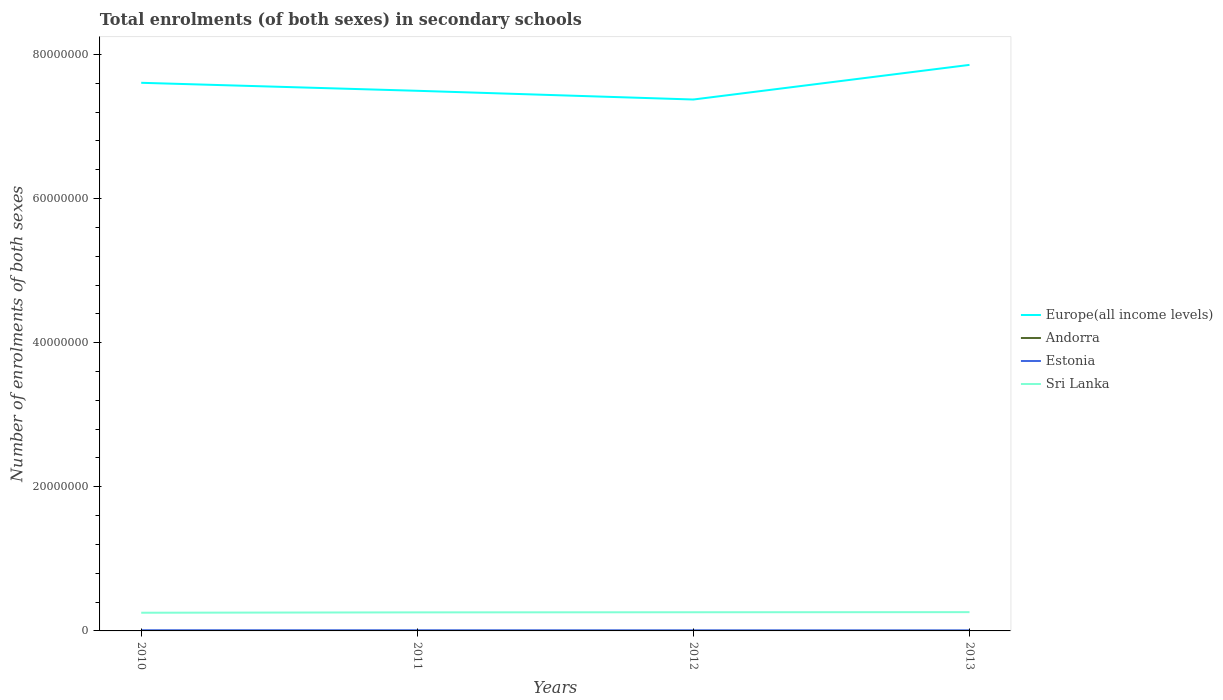Does the line corresponding to Europe(all income levels) intersect with the line corresponding to Andorra?
Keep it short and to the point. No. Across all years, what is the maximum number of enrolments in secondary schools in Estonia?
Ensure brevity in your answer.  8.08e+04. What is the total number of enrolments in secondary schools in Estonia in the graph?
Your response must be concise. 1.45e+04. What is the difference between the highest and the second highest number of enrolments in secondary schools in Estonia?
Your answer should be compact. 1.45e+04. Is the number of enrolments in secondary schools in Sri Lanka strictly greater than the number of enrolments in secondary schools in Andorra over the years?
Your answer should be compact. No. What is the difference between two consecutive major ticks on the Y-axis?
Offer a very short reply. 2.00e+07. Are the values on the major ticks of Y-axis written in scientific E-notation?
Offer a very short reply. No. Does the graph contain any zero values?
Give a very brief answer. No. How many legend labels are there?
Your response must be concise. 4. How are the legend labels stacked?
Provide a short and direct response. Vertical. What is the title of the graph?
Provide a succinct answer. Total enrolments (of both sexes) in secondary schools. What is the label or title of the X-axis?
Your response must be concise. Years. What is the label or title of the Y-axis?
Your answer should be compact. Number of enrolments of both sexes. What is the Number of enrolments of both sexes of Europe(all income levels) in 2010?
Make the answer very short. 7.61e+07. What is the Number of enrolments of both sexes of Andorra in 2010?
Keep it short and to the point. 4059. What is the Number of enrolments of both sexes of Estonia in 2010?
Your response must be concise. 9.53e+04. What is the Number of enrolments of both sexes in Sri Lanka in 2010?
Offer a terse response. 2.52e+06. What is the Number of enrolments of both sexes of Europe(all income levels) in 2011?
Provide a succinct answer. 7.50e+07. What is the Number of enrolments of both sexes in Andorra in 2011?
Offer a terse response. 4159. What is the Number of enrolments of both sexes in Estonia in 2011?
Ensure brevity in your answer.  9.07e+04. What is the Number of enrolments of both sexes of Sri Lanka in 2011?
Keep it short and to the point. 2.57e+06. What is the Number of enrolments of both sexes of Europe(all income levels) in 2012?
Provide a succinct answer. 7.37e+07. What is the Number of enrolments of both sexes in Andorra in 2012?
Offer a terse response. 4208. What is the Number of enrolments of both sexes in Estonia in 2012?
Offer a very short reply. 8.52e+04. What is the Number of enrolments of both sexes in Sri Lanka in 2012?
Ensure brevity in your answer.  2.59e+06. What is the Number of enrolments of both sexes of Europe(all income levels) in 2013?
Make the answer very short. 7.85e+07. What is the Number of enrolments of both sexes in Andorra in 2013?
Your answer should be very brief. 4239. What is the Number of enrolments of both sexes in Estonia in 2013?
Provide a succinct answer. 8.08e+04. What is the Number of enrolments of both sexes of Sri Lanka in 2013?
Offer a very short reply. 2.61e+06. Across all years, what is the maximum Number of enrolments of both sexes of Europe(all income levels)?
Provide a short and direct response. 7.85e+07. Across all years, what is the maximum Number of enrolments of both sexes of Andorra?
Offer a terse response. 4239. Across all years, what is the maximum Number of enrolments of both sexes of Estonia?
Give a very brief answer. 9.53e+04. Across all years, what is the maximum Number of enrolments of both sexes in Sri Lanka?
Provide a succinct answer. 2.61e+06. Across all years, what is the minimum Number of enrolments of both sexes in Europe(all income levels)?
Your answer should be very brief. 7.37e+07. Across all years, what is the minimum Number of enrolments of both sexes in Andorra?
Your response must be concise. 4059. Across all years, what is the minimum Number of enrolments of both sexes of Estonia?
Provide a succinct answer. 8.08e+04. Across all years, what is the minimum Number of enrolments of both sexes in Sri Lanka?
Ensure brevity in your answer.  2.52e+06. What is the total Number of enrolments of both sexes of Europe(all income levels) in the graph?
Provide a short and direct response. 3.03e+08. What is the total Number of enrolments of both sexes in Andorra in the graph?
Your response must be concise. 1.67e+04. What is the total Number of enrolments of both sexes of Estonia in the graph?
Provide a short and direct response. 3.52e+05. What is the total Number of enrolments of both sexes of Sri Lanka in the graph?
Keep it short and to the point. 1.03e+07. What is the difference between the Number of enrolments of both sexes of Europe(all income levels) in 2010 and that in 2011?
Offer a very short reply. 1.11e+06. What is the difference between the Number of enrolments of both sexes in Andorra in 2010 and that in 2011?
Your response must be concise. -100. What is the difference between the Number of enrolments of both sexes of Estonia in 2010 and that in 2011?
Offer a very short reply. 4614. What is the difference between the Number of enrolments of both sexes in Sri Lanka in 2010 and that in 2011?
Your answer should be compact. -4.92e+04. What is the difference between the Number of enrolments of both sexes in Europe(all income levels) in 2010 and that in 2012?
Offer a terse response. 2.32e+06. What is the difference between the Number of enrolments of both sexes in Andorra in 2010 and that in 2012?
Offer a terse response. -149. What is the difference between the Number of enrolments of both sexes of Estonia in 2010 and that in 2012?
Your answer should be very brief. 1.01e+04. What is the difference between the Number of enrolments of both sexes in Sri Lanka in 2010 and that in 2012?
Offer a terse response. -6.57e+04. What is the difference between the Number of enrolments of both sexes in Europe(all income levels) in 2010 and that in 2013?
Ensure brevity in your answer.  -2.49e+06. What is the difference between the Number of enrolments of both sexes in Andorra in 2010 and that in 2013?
Keep it short and to the point. -180. What is the difference between the Number of enrolments of both sexes of Estonia in 2010 and that in 2013?
Offer a very short reply. 1.45e+04. What is the difference between the Number of enrolments of both sexes of Sri Lanka in 2010 and that in 2013?
Offer a very short reply. -8.09e+04. What is the difference between the Number of enrolments of both sexes of Europe(all income levels) in 2011 and that in 2012?
Your response must be concise. 1.21e+06. What is the difference between the Number of enrolments of both sexes of Andorra in 2011 and that in 2012?
Offer a terse response. -49. What is the difference between the Number of enrolments of both sexes in Estonia in 2011 and that in 2012?
Provide a short and direct response. 5534. What is the difference between the Number of enrolments of both sexes in Sri Lanka in 2011 and that in 2012?
Provide a short and direct response. -1.65e+04. What is the difference between the Number of enrolments of both sexes in Europe(all income levels) in 2011 and that in 2013?
Provide a succinct answer. -3.60e+06. What is the difference between the Number of enrolments of both sexes in Andorra in 2011 and that in 2013?
Provide a short and direct response. -80. What is the difference between the Number of enrolments of both sexes of Estonia in 2011 and that in 2013?
Give a very brief answer. 9877. What is the difference between the Number of enrolments of both sexes in Sri Lanka in 2011 and that in 2013?
Make the answer very short. -3.18e+04. What is the difference between the Number of enrolments of both sexes in Europe(all income levels) in 2012 and that in 2013?
Give a very brief answer. -4.81e+06. What is the difference between the Number of enrolments of both sexes of Andorra in 2012 and that in 2013?
Offer a terse response. -31. What is the difference between the Number of enrolments of both sexes of Estonia in 2012 and that in 2013?
Keep it short and to the point. 4343. What is the difference between the Number of enrolments of both sexes of Sri Lanka in 2012 and that in 2013?
Your answer should be very brief. -1.52e+04. What is the difference between the Number of enrolments of both sexes of Europe(all income levels) in 2010 and the Number of enrolments of both sexes of Andorra in 2011?
Ensure brevity in your answer.  7.61e+07. What is the difference between the Number of enrolments of both sexes of Europe(all income levels) in 2010 and the Number of enrolments of both sexes of Estonia in 2011?
Offer a terse response. 7.60e+07. What is the difference between the Number of enrolments of both sexes of Europe(all income levels) in 2010 and the Number of enrolments of both sexes of Sri Lanka in 2011?
Your answer should be compact. 7.35e+07. What is the difference between the Number of enrolments of both sexes in Andorra in 2010 and the Number of enrolments of both sexes in Estonia in 2011?
Provide a succinct answer. -8.67e+04. What is the difference between the Number of enrolments of both sexes in Andorra in 2010 and the Number of enrolments of both sexes in Sri Lanka in 2011?
Offer a very short reply. -2.57e+06. What is the difference between the Number of enrolments of both sexes of Estonia in 2010 and the Number of enrolments of both sexes of Sri Lanka in 2011?
Your answer should be compact. -2.48e+06. What is the difference between the Number of enrolments of both sexes in Europe(all income levels) in 2010 and the Number of enrolments of both sexes in Andorra in 2012?
Your answer should be compact. 7.61e+07. What is the difference between the Number of enrolments of both sexes in Europe(all income levels) in 2010 and the Number of enrolments of both sexes in Estonia in 2012?
Offer a very short reply. 7.60e+07. What is the difference between the Number of enrolments of both sexes in Europe(all income levels) in 2010 and the Number of enrolments of both sexes in Sri Lanka in 2012?
Your response must be concise. 7.35e+07. What is the difference between the Number of enrolments of both sexes of Andorra in 2010 and the Number of enrolments of both sexes of Estonia in 2012?
Provide a succinct answer. -8.11e+04. What is the difference between the Number of enrolments of both sexes in Andorra in 2010 and the Number of enrolments of both sexes in Sri Lanka in 2012?
Ensure brevity in your answer.  -2.59e+06. What is the difference between the Number of enrolments of both sexes of Estonia in 2010 and the Number of enrolments of both sexes of Sri Lanka in 2012?
Give a very brief answer. -2.50e+06. What is the difference between the Number of enrolments of both sexes in Europe(all income levels) in 2010 and the Number of enrolments of both sexes in Andorra in 2013?
Provide a short and direct response. 7.61e+07. What is the difference between the Number of enrolments of both sexes of Europe(all income levels) in 2010 and the Number of enrolments of both sexes of Estonia in 2013?
Your answer should be compact. 7.60e+07. What is the difference between the Number of enrolments of both sexes in Europe(all income levels) in 2010 and the Number of enrolments of both sexes in Sri Lanka in 2013?
Provide a succinct answer. 7.35e+07. What is the difference between the Number of enrolments of both sexes of Andorra in 2010 and the Number of enrolments of both sexes of Estonia in 2013?
Provide a short and direct response. -7.68e+04. What is the difference between the Number of enrolments of both sexes in Andorra in 2010 and the Number of enrolments of both sexes in Sri Lanka in 2013?
Ensure brevity in your answer.  -2.60e+06. What is the difference between the Number of enrolments of both sexes of Estonia in 2010 and the Number of enrolments of both sexes of Sri Lanka in 2013?
Your response must be concise. -2.51e+06. What is the difference between the Number of enrolments of both sexes in Europe(all income levels) in 2011 and the Number of enrolments of both sexes in Andorra in 2012?
Offer a very short reply. 7.49e+07. What is the difference between the Number of enrolments of both sexes of Europe(all income levels) in 2011 and the Number of enrolments of both sexes of Estonia in 2012?
Offer a very short reply. 7.49e+07. What is the difference between the Number of enrolments of both sexes of Europe(all income levels) in 2011 and the Number of enrolments of both sexes of Sri Lanka in 2012?
Make the answer very short. 7.24e+07. What is the difference between the Number of enrolments of both sexes of Andorra in 2011 and the Number of enrolments of both sexes of Estonia in 2012?
Provide a succinct answer. -8.10e+04. What is the difference between the Number of enrolments of both sexes in Andorra in 2011 and the Number of enrolments of both sexes in Sri Lanka in 2012?
Provide a short and direct response. -2.59e+06. What is the difference between the Number of enrolments of both sexes in Estonia in 2011 and the Number of enrolments of both sexes in Sri Lanka in 2012?
Offer a terse response. -2.50e+06. What is the difference between the Number of enrolments of both sexes of Europe(all income levels) in 2011 and the Number of enrolments of both sexes of Andorra in 2013?
Offer a very short reply. 7.49e+07. What is the difference between the Number of enrolments of both sexes of Europe(all income levels) in 2011 and the Number of enrolments of both sexes of Estonia in 2013?
Keep it short and to the point. 7.49e+07. What is the difference between the Number of enrolments of both sexes in Europe(all income levels) in 2011 and the Number of enrolments of both sexes in Sri Lanka in 2013?
Your response must be concise. 7.23e+07. What is the difference between the Number of enrolments of both sexes of Andorra in 2011 and the Number of enrolments of both sexes of Estonia in 2013?
Offer a very short reply. -7.67e+04. What is the difference between the Number of enrolments of both sexes of Andorra in 2011 and the Number of enrolments of both sexes of Sri Lanka in 2013?
Offer a terse response. -2.60e+06. What is the difference between the Number of enrolments of both sexes of Estonia in 2011 and the Number of enrolments of both sexes of Sri Lanka in 2013?
Make the answer very short. -2.51e+06. What is the difference between the Number of enrolments of both sexes in Europe(all income levels) in 2012 and the Number of enrolments of both sexes in Andorra in 2013?
Offer a very short reply. 7.37e+07. What is the difference between the Number of enrolments of both sexes of Europe(all income levels) in 2012 and the Number of enrolments of both sexes of Estonia in 2013?
Ensure brevity in your answer.  7.37e+07. What is the difference between the Number of enrolments of both sexes of Europe(all income levels) in 2012 and the Number of enrolments of both sexes of Sri Lanka in 2013?
Give a very brief answer. 7.11e+07. What is the difference between the Number of enrolments of both sexes in Andorra in 2012 and the Number of enrolments of both sexes in Estonia in 2013?
Provide a short and direct response. -7.66e+04. What is the difference between the Number of enrolments of both sexes in Andorra in 2012 and the Number of enrolments of both sexes in Sri Lanka in 2013?
Make the answer very short. -2.60e+06. What is the difference between the Number of enrolments of both sexes of Estonia in 2012 and the Number of enrolments of both sexes of Sri Lanka in 2013?
Ensure brevity in your answer.  -2.52e+06. What is the average Number of enrolments of both sexes in Europe(all income levels) per year?
Provide a short and direct response. 7.58e+07. What is the average Number of enrolments of both sexes in Andorra per year?
Provide a short and direct response. 4166.25. What is the average Number of enrolments of both sexes of Estonia per year?
Offer a terse response. 8.80e+04. What is the average Number of enrolments of both sexes in Sri Lanka per year?
Ensure brevity in your answer.  2.57e+06. In the year 2010, what is the difference between the Number of enrolments of both sexes in Europe(all income levels) and Number of enrolments of both sexes in Andorra?
Your answer should be very brief. 7.61e+07. In the year 2010, what is the difference between the Number of enrolments of both sexes of Europe(all income levels) and Number of enrolments of both sexes of Estonia?
Your response must be concise. 7.60e+07. In the year 2010, what is the difference between the Number of enrolments of both sexes of Europe(all income levels) and Number of enrolments of both sexes of Sri Lanka?
Make the answer very short. 7.35e+07. In the year 2010, what is the difference between the Number of enrolments of both sexes of Andorra and Number of enrolments of both sexes of Estonia?
Your response must be concise. -9.13e+04. In the year 2010, what is the difference between the Number of enrolments of both sexes in Andorra and Number of enrolments of both sexes in Sri Lanka?
Ensure brevity in your answer.  -2.52e+06. In the year 2010, what is the difference between the Number of enrolments of both sexes in Estonia and Number of enrolments of both sexes in Sri Lanka?
Keep it short and to the point. -2.43e+06. In the year 2011, what is the difference between the Number of enrolments of both sexes in Europe(all income levels) and Number of enrolments of both sexes in Andorra?
Your response must be concise. 7.49e+07. In the year 2011, what is the difference between the Number of enrolments of both sexes of Europe(all income levels) and Number of enrolments of both sexes of Estonia?
Ensure brevity in your answer.  7.49e+07. In the year 2011, what is the difference between the Number of enrolments of both sexes of Europe(all income levels) and Number of enrolments of both sexes of Sri Lanka?
Your answer should be very brief. 7.24e+07. In the year 2011, what is the difference between the Number of enrolments of both sexes of Andorra and Number of enrolments of both sexes of Estonia?
Make the answer very short. -8.66e+04. In the year 2011, what is the difference between the Number of enrolments of both sexes of Andorra and Number of enrolments of both sexes of Sri Lanka?
Give a very brief answer. -2.57e+06. In the year 2011, what is the difference between the Number of enrolments of both sexes of Estonia and Number of enrolments of both sexes of Sri Lanka?
Your answer should be compact. -2.48e+06. In the year 2012, what is the difference between the Number of enrolments of both sexes in Europe(all income levels) and Number of enrolments of both sexes in Andorra?
Make the answer very short. 7.37e+07. In the year 2012, what is the difference between the Number of enrolments of both sexes of Europe(all income levels) and Number of enrolments of both sexes of Estonia?
Provide a succinct answer. 7.37e+07. In the year 2012, what is the difference between the Number of enrolments of both sexes of Europe(all income levels) and Number of enrolments of both sexes of Sri Lanka?
Your answer should be compact. 7.12e+07. In the year 2012, what is the difference between the Number of enrolments of both sexes in Andorra and Number of enrolments of both sexes in Estonia?
Make the answer very short. -8.10e+04. In the year 2012, what is the difference between the Number of enrolments of both sexes in Andorra and Number of enrolments of both sexes in Sri Lanka?
Keep it short and to the point. -2.59e+06. In the year 2012, what is the difference between the Number of enrolments of both sexes of Estonia and Number of enrolments of both sexes of Sri Lanka?
Make the answer very short. -2.51e+06. In the year 2013, what is the difference between the Number of enrolments of both sexes in Europe(all income levels) and Number of enrolments of both sexes in Andorra?
Ensure brevity in your answer.  7.85e+07. In the year 2013, what is the difference between the Number of enrolments of both sexes in Europe(all income levels) and Number of enrolments of both sexes in Estonia?
Keep it short and to the point. 7.85e+07. In the year 2013, what is the difference between the Number of enrolments of both sexes in Europe(all income levels) and Number of enrolments of both sexes in Sri Lanka?
Your answer should be very brief. 7.59e+07. In the year 2013, what is the difference between the Number of enrolments of both sexes in Andorra and Number of enrolments of both sexes in Estonia?
Give a very brief answer. -7.66e+04. In the year 2013, what is the difference between the Number of enrolments of both sexes of Andorra and Number of enrolments of both sexes of Sri Lanka?
Keep it short and to the point. -2.60e+06. In the year 2013, what is the difference between the Number of enrolments of both sexes of Estonia and Number of enrolments of both sexes of Sri Lanka?
Make the answer very short. -2.52e+06. What is the ratio of the Number of enrolments of both sexes of Europe(all income levels) in 2010 to that in 2011?
Make the answer very short. 1.01. What is the ratio of the Number of enrolments of both sexes in Estonia in 2010 to that in 2011?
Offer a terse response. 1.05. What is the ratio of the Number of enrolments of both sexes of Sri Lanka in 2010 to that in 2011?
Make the answer very short. 0.98. What is the ratio of the Number of enrolments of both sexes of Europe(all income levels) in 2010 to that in 2012?
Give a very brief answer. 1.03. What is the ratio of the Number of enrolments of both sexes of Andorra in 2010 to that in 2012?
Ensure brevity in your answer.  0.96. What is the ratio of the Number of enrolments of both sexes of Estonia in 2010 to that in 2012?
Provide a short and direct response. 1.12. What is the ratio of the Number of enrolments of both sexes in Sri Lanka in 2010 to that in 2012?
Offer a terse response. 0.97. What is the ratio of the Number of enrolments of both sexes in Europe(all income levels) in 2010 to that in 2013?
Offer a very short reply. 0.97. What is the ratio of the Number of enrolments of both sexes of Andorra in 2010 to that in 2013?
Offer a very short reply. 0.96. What is the ratio of the Number of enrolments of both sexes of Estonia in 2010 to that in 2013?
Make the answer very short. 1.18. What is the ratio of the Number of enrolments of both sexes of Sri Lanka in 2010 to that in 2013?
Provide a succinct answer. 0.97. What is the ratio of the Number of enrolments of both sexes in Europe(all income levels) in 2011 to that in 2012?
Ensure brevity in your answer.  1.02. What is the ratio of the Number of enrolments of both sexes of Andorra in 2011 to that in 2012?
Offer a very short reply. 0.99. What is the ratio of the Number of enrolments of both sexes of Estonia in 2011 to that in 2012?
Your answer should be compact. 1.06. What is the ratio of the Number of enrolments of both sexes of Europe(all income levels) in 2011 to that in 2013?
Your answer should be compact. 0.95. What is the ratio of the Number of enrolments of both sexes of Andorra in 2011 to that in 2013?
Offer a terse response. 0.98. What is the ratio of the Number of enrolments of both sexes of Estonia in 2011 to that in 2013?
Your answer should be very brief. 1.12. What is the ratio of the Number of enrolments of both sexes of Sri Lanka in 2011 to that in 2013?
Offer a terse response. 0.99. What is the ratio of the Number of enrolments of both sexes in Europe(all income levels) in 2012 to that in 2013?
Provide a succinct answer. 0.94. What is the ratio of the Number of enrolments of both sexes in Andorra in 2012 to that in 2013?
Your response must be concise. 0.99. What is the ratio of the Number of enrolments of both sexes in Estonia in 2012 to that in 2013?
Provide a succinct answer. 1.05. What is the ratio of the Number of enrolments of both sexes of Sri Lanka in 2012 to that in 2013?
Your response must be concise. 0.99. What is the difference between the highest and the second highest Number of enrolments of both sexes in Europe(all income levels)?
Ensure brevity in your answer.  2.49e+06. What is the difference between the highest and the second highest Number of enrolments of both sexes of Estonia?
Provide a succinct answer. 4614. What is the difference between the highest and the second highest Number of enrolments of both sexes in Sri Lanka?
Ensure brevity in your answer.  1.52e+04. What is the difference between the highest and the lowest Number of enrolments of both sexes of Europe(all income levels)?
Give a very brief answer. 4.81e+06. What is the difference between the highest and the lowest Number of enrolments of both sexes of Andorra?
Provide a short and direct response. 180. What is the difference between the highest and the lowest Number of enrolments of both sexes of Estonia?
Provide a succinct answer. 1.45e+04. What is the difference between the highest and the lowest Number of enrolments of both sexes of Sri Lanka?
Your answer should be very brief. 8.09e+04. 